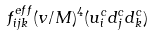Convert formula to latex. <formula><loc_0><loc_0><loc_500><loc_500>f ^ { e f f } _ { i j k } ( v / M ) ^ { 4 } ( u ^ { c } _ { i } d ^ { c } _ { j } d ^ { c } _ { k } )</formula> 